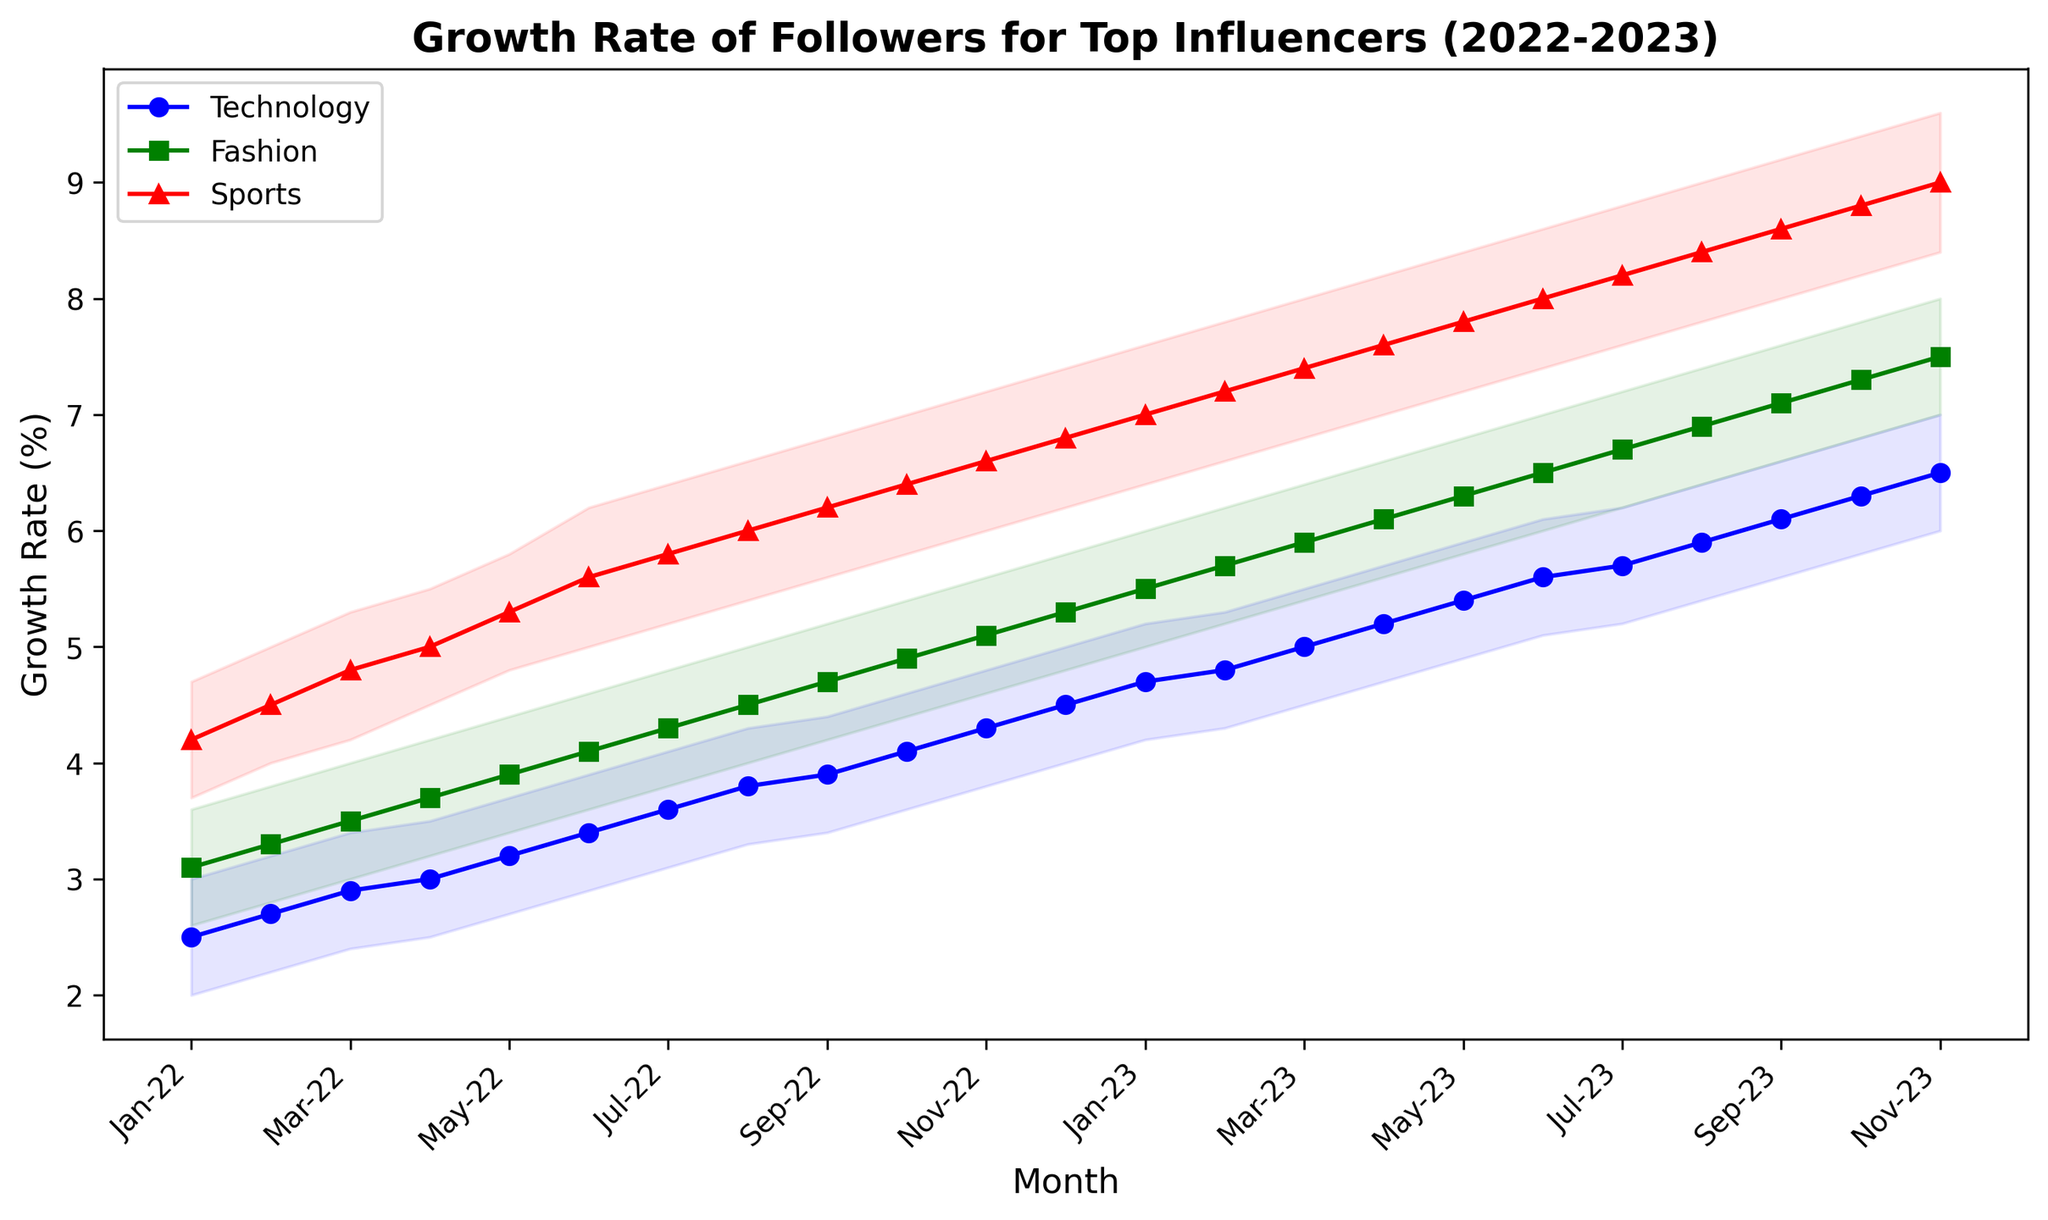What's the trend of the growth rate in the Technology category from Jan-22 to Nov-23? The trend shows a consistent increase in the growth rate of followers for the Technology category, starting at 2.5% in Jan-22 and reaching 6.5% in Nov-23.
Answer: Consistent increase Which category had the highest growth rate in Nov-22? By comparing the growth rate values in Nov-22, Technology had 4.3%, Fashion had 5.1%, and Sports had 6.6%. The Sports category had the highest growth rate in Nov-22.
Answer: Sports Is there any month where the growth rates of Technology and Fashion were equal? By comparing the growth rates month by month, one can see that there is no month where the growth rates of Technology and Fashion were equal.
Answer: No What is the difference in the growth rate of Sports between Jan-22 and Nov-23? In Jan-22, the growth rate of Sports was 4.2%, and in Nov-23, it was 9.0%. The difference is 9.0% - 4.2% = 4.8%.
Answer: 4.8% In which month did the Technology category first exceed a 4% growth rate? By examining the Technology growth rates, the first month the growth rate exceeded 4% was Oct-22, when it reached 4.1%.
Answer: Oct-22 What is the average growth rate of Fashion from Jan-22 to Nov-23? Sum the growth rates from Jan-22 to Nov-23 and divide by the number of months (i.e., 3.1 + 3.3 + 3.5 + 3.7 + 3.9 + 4.1 + 4.3 + 4.5 + 4.7 + 4.9 + 5.1 + 5.3 + 5.5 + 5.7 + 5.9 + 6.1 + 6.3 + 6.5 + 6.7 + 6.9 + 7.1 + 7.3 + 7.5) / 23 = 5.15
Answer: 5.15 Which category shows the most rapid increase in growth rate from Jan-22 to Nov-23? By observing the overall increase, Technology increases from 2.5% to 6.5% (+4.0%), Fashion from 3.1% to 7.5% (+4.4%), and Sports from 4.2% to 9.0% (+4.8%). Sports shows the most rapid increase.
Answer: Sports What is the growth rate range for the Technology category in Aug-23? The lower bound for Technology in Aug-23 is 5.4% and the upper bound is 6.4%, so the range is 6.4% - 5.4% = 1.0%.
Answer: 1.0% Compare the growth rate variability in Jul-22 between Fashion and Sports. The variability can be seen in the range of the growth rates. For Fashion in Jul-22, the range is 4.8% - 3.8% = 1.0%. For Sports in Jul-22, the range is 6.4% - 5.2% = 1.2%. Sports has higher variability.
Answer: Sports How does the average growth rate of Technology between Jul-22 and Jul-23 compare to that of Sports in the same period? Calculate the average growth rate for Technology (3.6 + 3.8 + 3.9 + 4.1 + 4.3 + 4.5 + 4.7 + 4.8 + 5.0 + 5.2 + 5.4 + 5.6 + 5.7) / 13 = 4.6%. For Sports, (5.8 + 6.0 + 6.2 + 6.4 + 6.6 + 6.8 + 7.0 + 7.2 + 7.4 + 7.6 + 7.8 + 8.0 + 8.2) / 13 = 6.9%. Sports shows a higher average growth rate.
Answer: Sports 